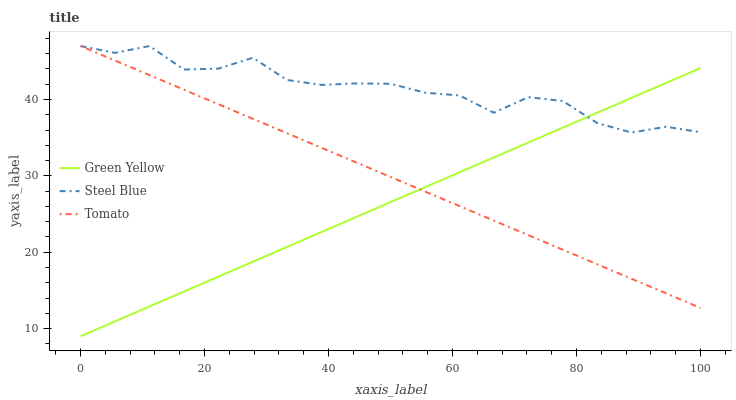Does Green Yellow have the minimum area under the curve?
Answer yes or no. Yes. Does Steel Blue have the maximum area under the curve?
Answer yes or no. Yes. Does Steel Blue have the minimum area under the curve?
Answer yes or no. No. Does Green Yellow have the maximum area under the curve?
Answer yes or no. No. Is Tomato the smoothest?
Answer yes or no. Yes. Is Steel Blue the roughest?
Answer yes or no. Yes. Is Green Yellow the smoothest?
Answer yes or no. No. Is Green Yellow the roughest?
Answer yes or no. No. Does Green Yellow have the lowest value?
Answer yes or no. Yes. Does Steel Blue have the lowest value?
Answer yes or no. No. Does Steel Blue have the highest value?
Answer yes or no. Yes. Does Green Yellow have the highest value?
Answer yes or no. No. Does Green Yellow intersect Steel Blue?
Answer yes or no. Yes. Is Green Yellow less than Steel Blue?
Answer yes or no. No. Is Green Yellow greater than Steel Blue?
Answer yes or no. No. 